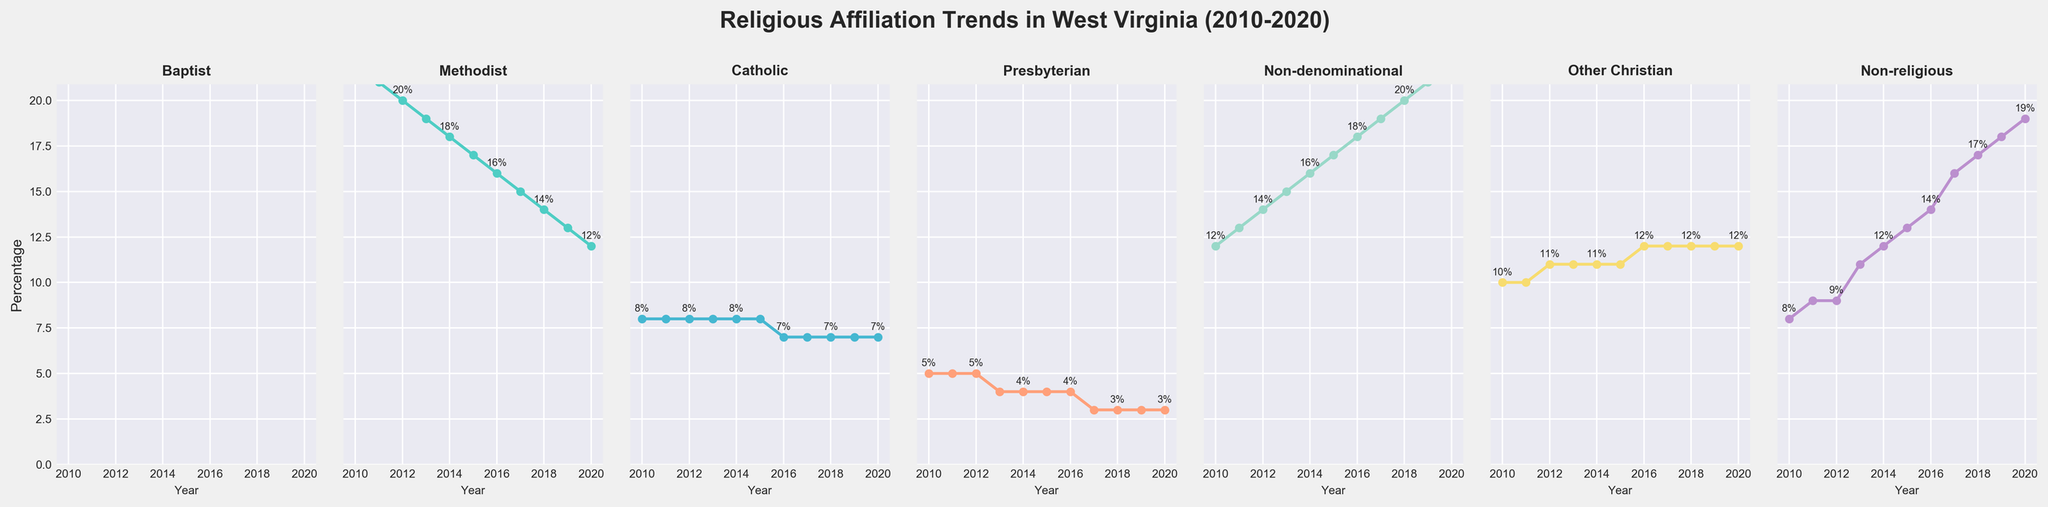What is the general trend for the Baptist denomination from 2010 to 2020? The Baptist denomination shows a decline from 35% in 2010 to 25% in 2020, consistently decreasing each year.
Answer: Decline Which denomination saw an increase in percentage the most from 2010 to 2020? The Non-denominational denomination increased from 12% in 2010 to 22% in 2020, making it the denomination with the largest increase of 10 percentage points.
Answer: Non-denominational In 2016, which denomination had the lowest percentage, and what was it? In 2016, the Presbyterian denomination had the lowest percentage, marked at 4%.
Answer: Presbyterian, 4% Compare the percentages of Catholic and Non-religious affiliations in 2020. Which one is higher, and by how much? In 2020, Catholic affiliation is 7% and Non-religious affiliation is 19%. Non-religious is higher by 12 percentage points (19% - 7% = 12%).
Answer: Non-religious by 12% What is the combined percentage of Methodist and Other Christian denominations in the year 2013? In 2013, the percentage for Methodist is 19% and for Other Christian is 11%. The combined percentage is 19% + 11% = 30%.
Answer: 30% Looking at the Presbyterian denomination, has there ever been an increase in any year from 2010 to 2020? The percentage for Presbyterian denomination has never increased and has either remained the same or decreased; from 5% in 2010 to 3% in 2020.
Answer: No How many denominations had a percentage increase from 2010 to 2020? By reviewing each subplot, it is evident that Non-denominational, Other Christian, and Non-religious denominations saw an increase, totaling 3 denominations.
Answer: 3 What is the overall average percentage for the Non-religious affiliation between 2010 and 2020? The percentages for Non-religious affiliation from 2010 to 2020 are: 8, 9, 9, 11, 12, 13, 14, 16, 17, 18, 19. Summing these values gives 146, and there are 11 data points, so the average is 146/11 ≈ 13.27%.
Answer: ≈ 13.27% Which denomination had a consistently declining trend throughout 2010 to 2020? The Baptist denomination consistently declined each year from 35% in 2010 to 25% in 2020.
Answer: Baptist What is the difference in percentage between Methodist and Non-denominational affiliations in 2018? In 2018, the percentage for Methodist is 14% and for Non-denominational is 20%. The difference is 20% - 14% = 6%.
Answer: 6% 